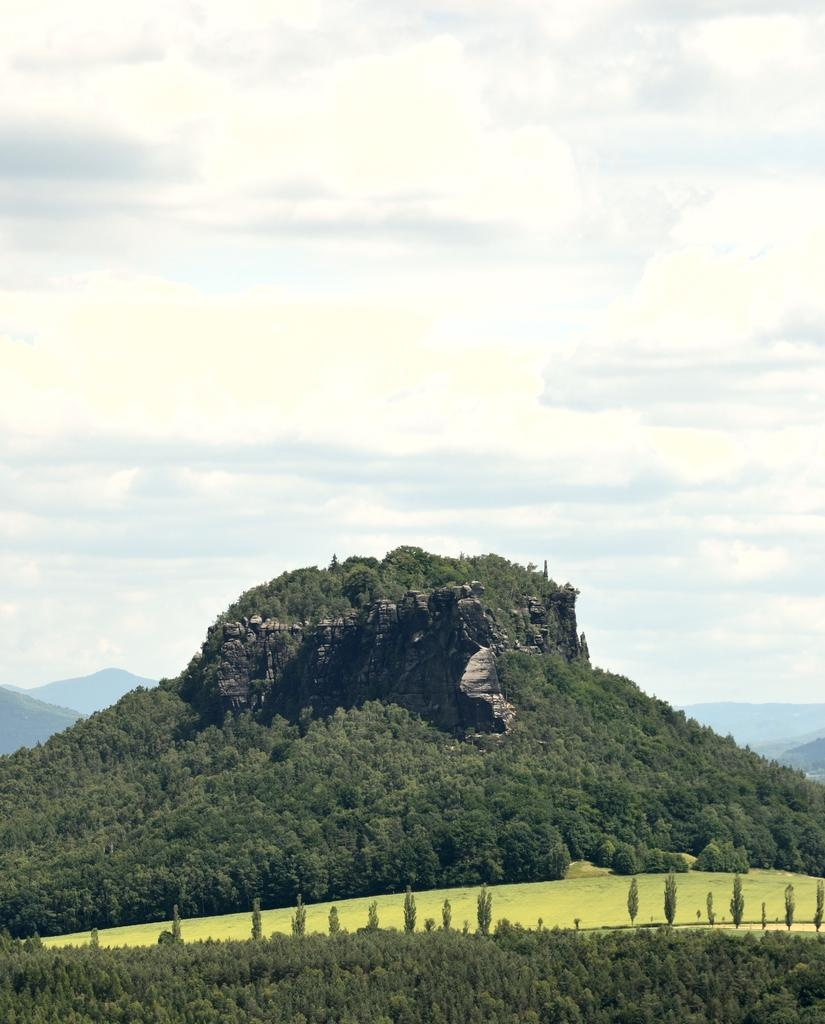What type of vegetation is at the bottom of the image? There are trees at the bottom of the image. What type of vegetation is in the middle of the image? There is grass in the middle of the image. What can be seen in the background of the image? There are trees and hills in the background of the image. What is visible at the top of the image? The sky is visible at the top of the image. What can be observed in the sky? Clouds are present in the sky. How many boats are visible in the image? There are no boats present in the image. What is the weight of the turkey in the image? There is no turkey present in the image. 